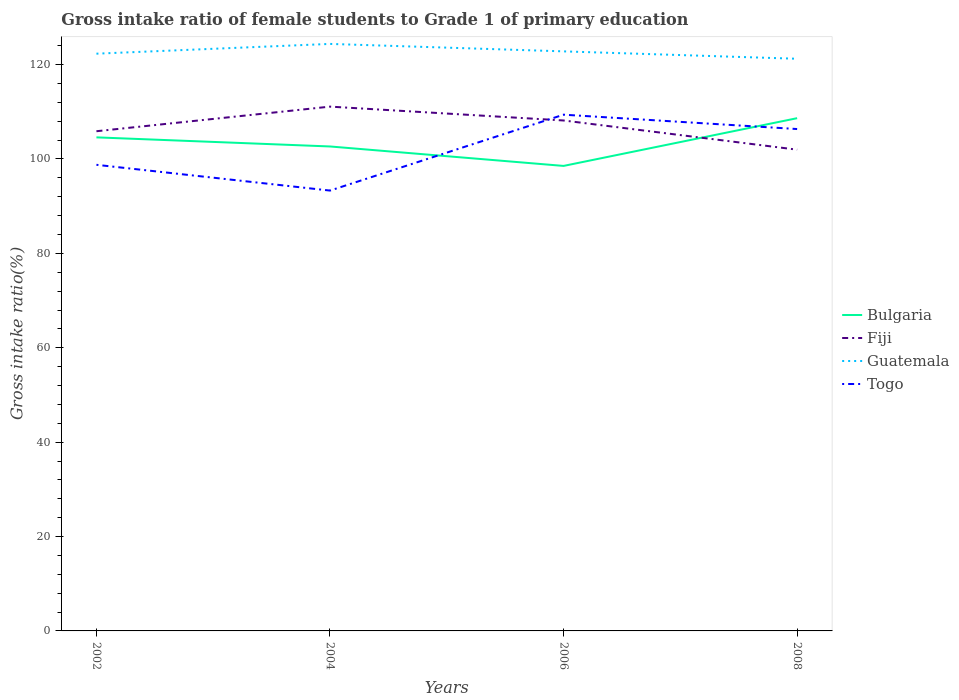Is the number of lines equal to the number of legend labels?
Make the answer very short. Yes. Across all years, what is the maximum gross intake ratio in Fiji?
Offer a terse response. 101.97. In which year was the gross intake ratio in Guatemala maximum?
Offer a very short reply. 2008. What is the total gross intake ratio in Guatemala in the graph?
Give a very brief answer. 1.08. What is the difference between the highest and the second highest gross intake ratio in Bulgaria?
Keep it short and to the point. 10.12. Is the gross intake ratio in Fiji strictly greater than the gross intake ratio in Bulgaria over the years?
Your response must be concise. No. How many lines are there?
Offer a very short reply. 4. How many years are there in the graph?
Provide a short and direct response. 4. What is the difference between two consecutive major ticks on the Y-axis?
Offer a terse response. 20. Does the graph contain grids?
Make the answer very short. No. Where does the legend appear in the graph?
Ensure brevity in your answer.  Center right. How many legend labels are there?
Ensure brevity in your answer.  4. What is the title of the graph?
Offer a very short reply. Gross intake ratio of female students to Grade 1 of primary education. What is the label or title of the Y-axis?
Ensure brevity in your answer.  Gross intake ratio(%). What is the Gross intake ratio(%) of Bulgaria in 2002?
Make the answer very short. 104.58. What is the Gross intake ratio(%) of Fiji in 2002?
Make the answer very short. 105.88. What is the Gross intake ratio(%) of Guatemala in 2002?
Offer a terse response. 122.31. What is the Gross intake ratio(%) in Togo in 2002?
Your response must be concise. 98.77. What is the Gross intake ratio(%) in Bulgaria in 2004?
Make the answer very short. 102.65. What is the Gross intake ratio(%) in Fiji in 2004?
Your answer should be very brief. 111.1. What is the Gross intake ratio(%) in Guatemala in 2004?
Your answer should be very brief. 124.38. What is the Gross intake ratio(%) of Togo in 2004?
Provide a succinct answer. 93.31. What is the Gross intake ratio(%) in Bulgaria in 2006?
Your answer should be very brief. 98.53. What is the Gross intake ratio(%) in Fiji in 2006?
Give a very brief answer. 108.16. What is the Gross intake ratio(%) in Guatemala in 2006?
Give a very brief answer. 122.8. What is the Gross intake ratio(%) of Togo in 2006?
Your response must be concise. 109.39. What is the Gross intake ratio(%) of Bulgaria in 2008?
Ensure brevity in your answer.  108.65. What is the Gross intake ratio(%) of Fiji in 2008?
Your response must be concise. 101.97. What is the Gross intake ratio(%) of Guatemala in 2008?
Offer a terse response. 121.24. What is the Gross intake ratio(%) of Togo in 2008?
Make the answer very short. 106.35. Across all years, what is the maximum Gross intake ratio(%) of Bulgaria?
Make the answer very short. 108.65. Across all years, what is the maximum Gross intake ratio(%) of Fiji?
Make the answer very short. 111.1. Across all years, what is the maximum Gross intake ratio(%) in Guatemala?
Offer a very short reply. 124.38. Across all years, what is the maximum Gross intake ratio(%) of Togo?
Provide a succinct answer. 109.39. Across all years, what is the minimum Gross intake ratio(%) in Bulgaria?
Provide a succinct answer. 98.53. Across all years, what is the minimum Gross intake ratio(%) of Fiji?
Ensure brevity in your answer.  101.97. Across all years, what is the minimum Gross intake ratio(%) in Guatemala?
Give a very brief answer. 121.24. Across all years, what is the minimum Gross intake ratio(%) in Togo?
Ensure brevity in your answer.  93.31. What is the total Gross intake ratio(%) in Bulgaria in the graph?
Provide a short and direct response. 414.42. What is the total Gross intake ratio(%) of Fiji in the graph?
Your answer should be very brief. 427.11. What is the total Gross intake ratio(%) of Guatemala in the graph?
Your answer should be compact. 490.74. What is the total Gross intake ratio(%) of Togo in the graph?
Give a very brief answer. 407.81. What is the difference between the Gross intake ratio(%) in Bulgaria in 2002 and that in 2004?
Keep it short and to the point. 1.93. What is the difference between the Gross intake ratio(%) of Fiji in 2002 and that in 2004?
Keep it short and to the point. -5.21. What is the difference between the Gross intake ratio(%) of Guatemala in 2002 and that in 2004?
Make the answer very short. -2.07. What is the difference between the Gross intake ratio(%) of Togo in 2002 and that in 2004?
Your answer should be compact. 5.46. What is the difference between the Gross intake ratio(%) in Bulgaria in 2002 and that in 2006?
Offer a terse response. 6.05. What is the difference between the Gross intake ratio(%) of Fiji in 2002 and that in 2006?
Provide a succinct answer. -2.28. What is the difference between the Gross intake ratio(%) of Guatemala in 2002 and that in 2006?
Ensure brevity in your answer.  -0.49. What is the difference between the Gross intake ratio(%) of Togo in 2002 and that in 2006?
Provide a succinct answer. -10.62. What is the difference between the Gross intake ratio(%) in Bulgaria in 2002 and that in 2008?
Your answer should be very brief. -4.06. What is the difference between the Gross intake ratio(%) of Fiji in 2002 and that in 2008?
Provide a short and direct response. 3.91. What is the difference between the Gross intake ratio(%) in Guatemala in 2002 and that in 2008?
Offer a terse response. 1.08. What is the difference between the Gross intake ratio(%) of Togo in 2002 and that in 2008?
Provide a succinct answer. -7.58. What is the difference between the Gross intake ratio(%) of Bulgaria in 2004 and that in 2006?
Make the answer very short. 4.12. What is the difference between the Gross intake ratio(%) of Fiji in 2004 and that in 2006?
Provide a short and direct response. 2.94. What is the difference between the Gross intake ratio(%) in Guatemala in 2004 and that in 2006?
Provide a short and direct response. 1.58. What is the difference between the Gross intake ratio(%) in Togo in 2004 and that in 2006?
Provide a succinct answer. -16.08. What is the difference between the Gross intake ratio(%) in Bulgaria in 2004 and that in 2008?
Your answer should be very brief. -5.99. What is the difference between the Gross intake ratio(%) in Fiji in 2004 and that in 2008?
Offer a terse response. 9.12. What is the difference between the Gross intake ratio(%) of Guatemala in 2004 and that in 2008?
Your answer should be compact. 3.15. What is the difference between the Gross intake ratio(%) in Togo in 2004 and that in 2008?
Your response must be concise. -13.04. What is the difference between the Gross intake ratio(%) in Bulgaria in 2006 and that in 2008?
Offer a terse response. -10.12. What is the difference between the Gross intake ratio(%) in Fiji in 2006 and that in 2008?
Provide a short and direct response. 6.19. What is the difference between the Gross intake ratio(%) in Guatemala in 2006 and that in 2008?
Offer a terse response. 1.57. What is the difference between the Gross intake ratio(%) in Togo in 2006 and that in 2008?
Offer a very short reply. 3.04. What is the difference between the Gross intake ratio(%) of Bulgaria in 2002 and the Gross intake ratio(%) of Fiji in 2004?
Provide a succinct answer. -6.51. What is the difference between the Gross intake ratio(%) of Bulgaria in 2002 and the Gross intake ratio(%) of Guatemala in 2004?
Give a very brief answer. -19.8. What is the difference between the Gross intake ratio(%) of Bulgaria in 2002 and the Gross intake ratio(%) of Togo in 2004?
Offer a very short reply. 11.28. What is the difference between the Gross intake ratio(%) in Fiji in 2002 and the Gross intake ratio(%) in Guatemala in 2004?
Offer a very short reply. -18.5. What is the difference between the Gross intake ratio(%) of Fiji in 2002 and the Gross intake ratio(%) of Togo in 2004?
Your answer should be compact. 12.58. What is the difference between the Gross intake ratio(%) of Guatemala in 2002 and the Gross intake ratio(%) of Togo in 2004?
Provide a short and direct response. 29.01. What is the difference between the Gross intake ratio(%) of Bulgaria in 2002 and the Gross intake ratio(%) of Fiji in 2006?
Offer a terse response. -3.58. What is the difference between the Gross intake ratio(%) of Bulgaria in 2002 and the Gross intake ratio(%) of Guatemala in 2006?
Your response must be concise. -18.22. What is the difference between the Gross intake ratio(%) in Bulgaria in 2002 and the Gross intake ratio(%) in Togo in 2006?
Provide a short and direct response. -4.81. What is the difference between the Gross intake ratio(%) in Fiji in 2002 and the Gross intake ratio(%) in Guatemala in 2006?
Give a very brief answer. -16.92. What is the difference between the Gross intake ratio(%) in Fiji in 2002 and the Gross intake ratio(%) in Togo in 2006?
Your answer should be very brief. -3.51. What is the difference between the Gross intake ratio(%) in Guatemala in 2002 and the Gross intake ratio(%) in Togo in 2006?
Provide a succinct answer. 12.93. What is the difference between the Gross intake ratio(%) of Bulgaria in 2002 and the Gross intake ratio(%) of Fiji in 2008?
Make the answer very short. 2.61. What is the difference between the Gross intake ratio(%) of Bulgaria in 2002 and the Gross intake ratio(%) of Guatemala in 2008?
Provide a succinct answer. -16.65. What is the difference between the Gross intake ratio(%) of Bulgaria in 2002 and the Gross intake ratio(%) of Togo in 2008?
Make the answer very short. -1.76. What is the difference between the Gross intake ratio(%) of Fiji in 2002 and the Gross intake ratio(%) of Guatemala in 2008?
Your answer should be compact. -15.35. What is the difference between the Gross intake ratio(%) of Fiji in 2002 and the Gross intake ratio(%) of Togo in 2008?
Provide a succinct answer. -0.46. What is the difference between the Gross intake ratio(%) in Guatemala in 2002 and the Gross intake ratio(%) in Togo in 2008?
Provide a short and direct response. 15.97. What is the difference between the Gross intake ratio(%) of Bulgaria in 2004 and the Gross intake ratio(%) of Fiji in 2006?
Ensure brevity in your answer.  -5.51. What is the difference between the Gross intake ratio(%) in Bulgaria in 2004 and the Gross intake ratio(%) in Guatemala in 2006?
Provide a succinct answer. -20.15. What is the difference between the Gross intake ratio(%) of Bulgaria in 2004 and the Gross intake ratio(%) of Togo in 2006?
Your response must be concise. -6.73. What is the difference between the Gross intake ratio(%) of Fiji in 2004 and the Gross intake ratio(%) of Guatemala in 2006?
Make the answer very short. -11.71. What is the difference between the Gross intake ratio(%) in Fiji in 2004 and the Gross intake ratio(%) in Togo in 2006?
Keep it short and to the point. 1.71. What is the difference between the Gross intake ratio(%) in Guatemala in 2004 and the Gross intake ratio(%) in Togo in 2006?
Your answer should be very brief. 15. What is the difference between the Gross intake ratio(%) in Bulgaria in 2004 and the Gross intake ratio(%) in Fiji in 2008?
Provide a short and direct response. 0.68. What is the difference between the Gross intake ratio(%) of Bulgaria in 2004 and the Gross intake ratio(%) of Guatemala in 2008?
Your response must be concise. -18.58. What is the difference between the Gross intake ratio(%) in Bulgaria in 2004 and the Gross intake ratio(%) in Togo in 2008?
Give a very brief answer. -3.69. What is the difference between the Gross intake ratio(%) of Fiji in 2004 and the Gross intake ratio(%) of Guatemala in 2008?
Provide a succinct answer. -10.14. What is the difference between the Gross intake ratio(%) in Fiji in 2004 and the Gross intake ratio(%) in Togo in 2008?
Your answer should be very brief. 4.75. What is the difference between the Gross intake ratio(%) of Guatemala in 2004 and the Gross intake ratio(%) of Togo in 2008?
Offer a very short reply. 18.04. What is the difference between the Gross intake ratio(%) in Bulgaria in 2006 and the Gross intake ratio(%) in Fiji in 2008?
Offer a very short reply. -3.44. What is the difference between the Gross intake ratio(%) of Bulgaria in 2006 and the Gross intake ratio(%) of Guatemala in 2008?
Your response must be concise. -22.7. What is the difference between the Gross intake ratio(%) of Bulgaria in 2006 and the Gross intake ratio(%) of Togo in 2008?
Provide a succinct answer. -7.81. What is the difference between the Gross intake ratio(%) in Fiji in 2006 and the Gross intake ratio(%) in Guatemala in 2008?
Give a very brief answer. -13.08. What is the difference between the Gross intake ratio(%) in Fiji in 2006 and the Gross intake ratio(%) in Togo in 2008?
Keep it short and to the point. 1.81. What is the difference between the Gross intake ratio(%) of Guatemala in 2006 and the Gross intake ratio(%) of Togo in 2008?
Offer a very short reply. 16.46. What is the average Gross intake ratio(%) of Bulgaria per year?
Offer a terse response. 103.6. What is the average Gross intake ratio(%) of Fiji per year?
Ensure brevity in your answer.  106.78. What is the average Gross intake ratio(%) in Guatemala per year?
Your response must be concise. 122.69. What is the average Gross intake ratio(%) in Togo per year?
Give a very brief answer. 101.95. In the year 2002, what is the difference between the Gross intake ratio(%) of Bulgaria and Gross intake ratio(%) of Guatemala?
Make the answer very short. -17.73. In the year 2002, what is the difference between the Gross intake ratio(%) in Bulgaria and Gross intake ratio(%) in Togo?
Give a very brief answer. 5.82. In the year 2002, what is the difference between the Gross intake ratio(%) in Fiji and Gross intake ratio(%) in Guatemala?
Provide a short and direct response. -16.43. In the year 2002, what is the difference between the Gross intake ratio(%) of Fiji and Gross intake ratio(%) of Togo?
Provide a short and direct response. 7.12. In the year 2002, what is the difference between the Gross intake ratio(%) in Guatemala and Gross intake ratio(%) in Togo?
Offer a terse response. 23.55. In the year 2004, what is the difference between the Gross intake ratio(%) of Bulgaria and Gross intake ratio(%) of Fiji?
Your answer should be compact. -8.44. In the year 2004, what is the difference between the Gross intake ratio(%) of Bulgaria and Gross intake ratio(%) of Guatemala?
Give a very brief answer. -21.73. In the year 2004, what is the difference between the Gross intake ratio(%) of Bulgaria and Gross intake ratio(%) of Togo?
Provide a short and direct response. 9.35. In the year 2004, what is the difference between the Gross intake ratio(%) of Fiji and Gross intake ratio(%) of Guatemala?
Ensure brevity in your answer.  -13.29. In the year 2004, what is the difference between the Gross intake ratio(%) in Fiji and Gross intake ratio(%) in Togo?
Offer a very short reply. 17.79. In the year 2004, what is the difference between the Gross intake ratio(%) in Guatemala and Gross intake ratio(%) in Togo?
Keep it short and to the point. 31.08. In the year 2006, what is the difference between the Gross intake ratio(%) of Bulgaria and Gross intake ratio(%) of Fiji?
Ensure brevity in your answer.  -9.63. In the year 2006, what is the difference between the Gross intake ratio(%) of Bulgaria and Gross intake ratio(%) of Guatemala?
Provide a short and direct response. -24.27. In the year 2006, what is the difference between the Gross intake ratio(%) in Bulgaria and Gross intake ratio(%) in Togo?
Provide a succinct answer. -10.86. In the year 2006, what is the difference between the Gross intake ratio(%) in Fiji and Gross intake ratio(%) in Guatemala?
Ensure brevity in your answer.  -14.65. In the year 2006, what is the difference between the Gross intake ratio(%) of Fiji and Gross intake ratio(%) of Togo?
Your response must be concise. -1.23. In the year 2006, what is the difference between the Gross intake ratio(%) in Guatemala and Gross intake ratio(%) in Togo?
Keep it short and to the point. 13.42. In the year 2008, what is the difference between the Gross intake ratio(%) in Bulgaria and Gross intake ratio(%) in Fiji?
Make the answer very short. 6.67. In the year 2008, what is the difference between the Gross intake ratio(%) of Bulgaria and Gross intake ratio(%) of Guatemala?
Offer a very short reply. -12.59. In the year 2008, what is the difference between the Gross intake ratio(%) in Bulgaria and Gross intake ratio(%) in Togo?
Ensure brevity in your answer.  2.3. In the year 2008, what is the difference between the Gross intake ratio(%) in Fiji and Gross intake ratio(%) in Guatemala?
Provide a short and direct response. -19.26. In the year 2008, what is the difference between the Gross intake ratio(%) in Fiji and Gross intake ratio(%) in Togo?
Offer a very short reply. -4.37. In the year 2008, what is the difference between the Gross intake ratio(%) of Guatemala and Gross intake ratio(%) of Togo?
Keep it short and to the point. 14.89. What is the ratio of the Gross intake ratio(%) in Bulgaria in 2002 to that in 2004?
Offer a very short reply. 1.02. What is the ratio of the Gross intake ratio(%) in Fiji in 2002 to that in 2004?
Offer a very short reply. 0.95. What is the ratio of the Gross intake ratio(%) in Guatemala in 2002 to that in 2004?
Your answer should be very brief. 0.98. What is the ratio of the Gross intake ratio(%) in Togo in 2002 to that in 2004?
Your answer should be very brief. 1.06. What is the ratio of the Gross intake ratio(%) of Bulgaria in 2002 to that in 2006?
Your answer should be compact. 1.06. What is the ratio of the Gross intake ratio(%) of Fiji in 2002 to that in 2006?
Make the answer very short. 0.98. What is the ratio of the Gross intake ratio(%) of Guatemala in 2002 to that in 2006?
Offer a very short reply. 1. What is the ratio of the Gross intake ratio(%) of Togo in 2002 to that in 2006?
Make the answer very short. 0.9. What is the ratio of the Gross intake ratio(%) in Bulgaria in 2002 to that in 2008?
Your response must be concise. 0.96. What is the ratio of the Gross intake ratio(%) of Fiji in 2002 to that in 2008?
Keep it short and to the point. 1.04. What is the ratio of the Gross intake ratio(%) in Guatemala in 2002 to that in 2008?
Ensure brevity in your answer.  1.01. What is the ratio of the Gross intake ratio(%) of Togo in 2002 to that in 2008?
Offer a terse response. 0.93. What is the ratio of the Gross intake ratio(%) in Bulgaria in 2004 to that in 2006?
Give a very brief answer. 1.04. What is the ratio of the Gross intake ratio(%) of Fiji in 2004 to that in 2006?
Your response must be concise. 1.03. What is the ratio of the Gross intake ratio(%) of Guatemala in 2004 to that in 2006?
Make the answer very short. 1.01. What is the ratio of the Gross intake ratio(%) of Togo in 2004 to that in 2006?
Give a very brief answer. 0.85. What is the ratio of the Gross intake ratio(%) in Bulgaria in 2004 to that in 2008?
Ensure brevity in your answer.  0.94. What is the ratio of the Gross intake ratio(%) of Fiji in 2004 to that in 2008?
Your answer should be very brief. 1.09. What is the ratio of the Gross intake ratio(%) in Guatemala in 2004 to that in 2008?
Ensure brevity in your answer.  1.03. What is the ratio of the Gross intake ratio(%) in Togo in 2004 to that in 2008?
Your answer should be compact. 0.88. What is the ratio of the Gross intake ratio(%) of Bulgaria in 2006 to that in 2008?
Offer a terse response. 0.91. What is the ratio of the Gross intake ratio(%) of Fiji in 2006 to that in 2008?
Offer a very short reply. 1.06. What is the ratio of the Gross intake ratio(%) in Guatemala in 2006 to that in 2008?
Provide a short and direct response. 1.01. What is the ratio of the Gross intake ratio(%) in Togo in 2006 to that in 2008?
Make the answer very short. 1.03. What is the difference between the highest and the second highest Gross intake ratio(%) of Bulgaria?
Offer a very short reply. 4.06. What is the difference between the highest and the second highest Gross intake ratio(%) in Fiji?
Ensure brevity in your answer.  2.94. What is the difference between the highest and the second highest Gross intake ratio(%) in Guatemala?
Ensure brevity in your answer.  1.58. What is the difference between the highest and the second highest Gross intake ratio(%) in Togo?
Your answer should be compact. 3.04. What is the difference between the highest and the lowest Gross intake ratio(%) in Bulgaria?
Ensure brevity in your answer.  10.12. What is the difference between the highest and the lowest Gross intake ratio(%) in Fiji?
Keep it short and to the point. 9.12. What is the difference between the highest and the lowest Gross intake ratio(%) of Guatemala?
Offer a very short reply. 3.15. What is the difference between the highest and the lowest Gross intake ratio(%) in Togo?
Provide a succinct answer. 16.08. 